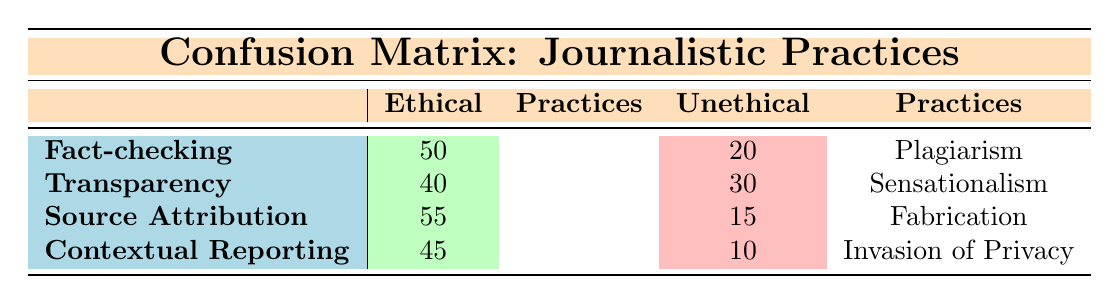What is the value for fact-checking under ethical practices? The table directly shows the value under the row for fact-checking in the column for ethical practices, which is 50.
Answer: 50 How many cases of sensationalism are identified as unethical practices? The table provides a direct reference to sensationalism under the unethical practices column and shows that there are 30 cases.
Answer: 30 What is the total number of ethical practices reported in the table? To find the total ethical practices, sum the values for fact-checking (50), transparency (40), source attribution (55), and contextual reporting (45). This equals 50 + 40 + 55 + 45 = 190.
Answer: 190 Is the number of cases of invasion of privacy higher than that of fabrication? The table lists invasion of privacy as 10 and fabrication as 15. Since 10 is less than 15, the statement is false.
Answer: No What is the difference between the highest and lowest values in unethical practices? The highest value is for sensationalism (30) and the lowest for invasion of privacy (10). The difference is calculated as 30 - 10 = 20.
Answer: 20 Which ethical practice has the highest count, and what is that count? By examining the values under ethical practices, source attribution has the highest count at 55, compared to the others.
Answer: Source attribution, 55 What percentage of the total ethical practices is attributed to fact-checking? The total ethical practices is 190, and fact-checking has a count of 50. To find the percentage, use (50/190) * 100, which equals approximately 26.32%.
Answer: 26.32% Are most unethical practices reported more than 20 cases? By reviewing the values, plagiarism (20), sensationalism (30), fabrication (15), and invasion of privacy (10) show that only sensationalism exceeds 20; therefore, most do not.
Answer: No What is the average value of ethical practices reported in the table? To find the average, sum all ethical practice values: 50 + 40 + 55 + 45 = 190. There are 4 data points, so divide 190 by 4, yielding 47.5.
Answer: 47.5 